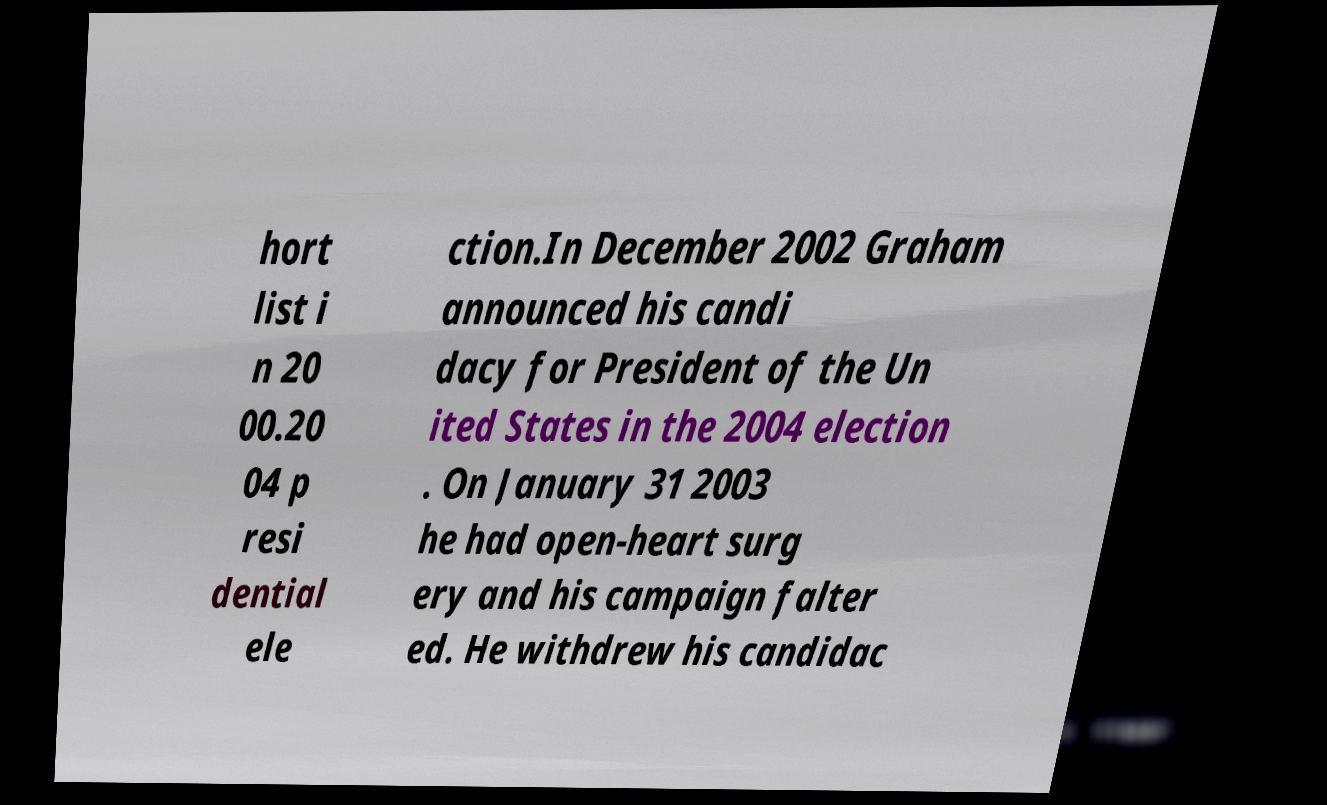Can you accurately transcribe the text from the provided image for me? hort list i n 20 00.20 04 p resi dential ele ction.In December 2002 Graham announced his candi dacy for President of the Un ited States in the 2004 election . On January 31 2003 he had open-heart surg ery and his campaign falter ed. He withdrew his candidac 